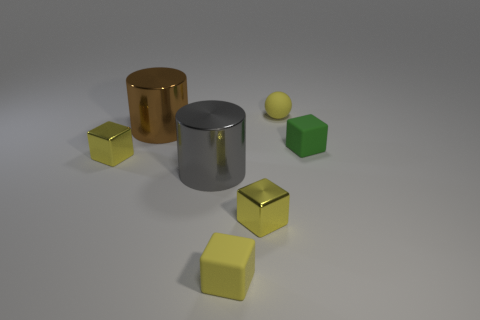Add 2 big blue spheres. How many objects exist? 9 Subtract all yellow cubes. How many cubes are left? 1 Subtract 2 yellow cubes. How many objects are left? 5 Subtract all cylinders. How many objects are left? 5 Subtract 3 cubes. How many cubes are left? 1 Subtract all purple spheres. Subtract all gray blocks. How many spheres are left? 1 Subtract all gray cylinders. How many gray cubes are left? 0 Subtract all red matte spheres. Subtract all yellow matte balls. How many objects are left? 6 Add 2 rubber spheres. How many rubber spheres are left? 3 Add 3 blue matte blocks. How many blue matte blocks exist? 3 